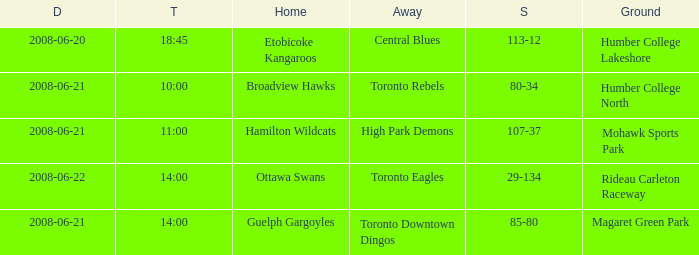What is the Away with a Ground that is humber college north? Toronto Rebels. 